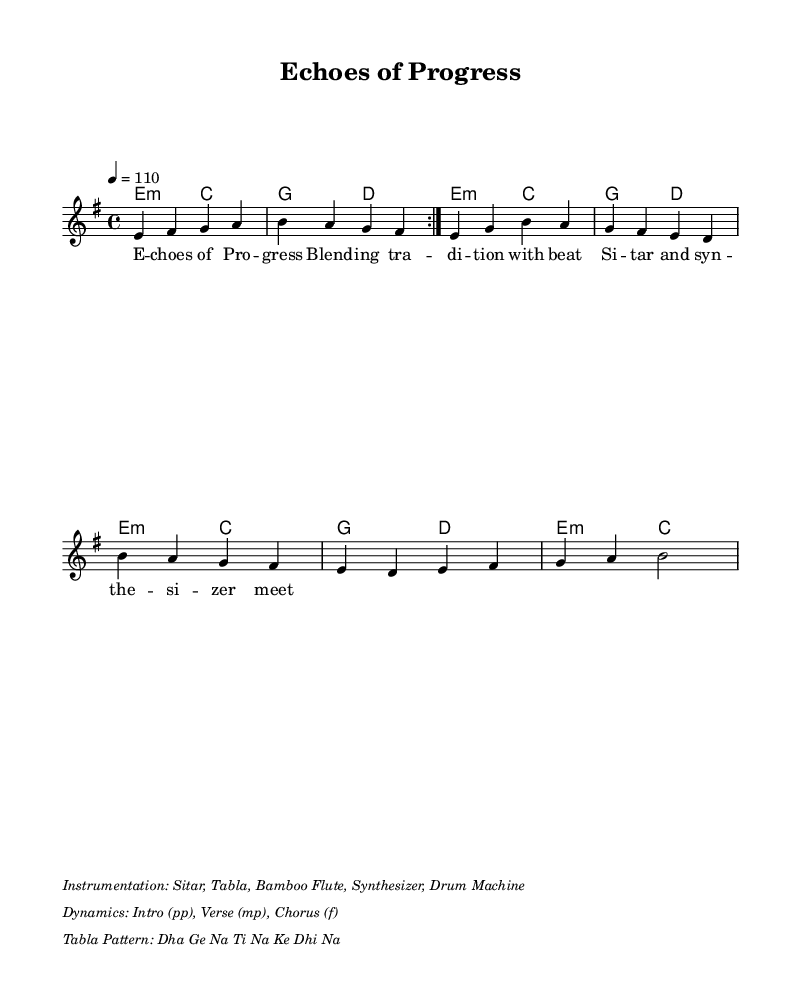What is the key signature of this music? The key signature is indicated by the sharp signs (the F#) in the sheet music, which reveals that it is in E minor.
Answer: E minor What is the time signature of the piece? The time signature is found at the beginning of the score; since it shows 4/4, this indicates that there are four beats in a measure and a quarter note gets one beat.
Answer: 4/4 What is the tempo marking of the music? The tempo is specified at the start with "4 = 110," which means there are 110 beats per minute, providing a fast pace to the music.
Answer: 110 How many times is the intro repeated? The score indicates "repeat volta 2" for the intro, meaning it should be played twice before moving to the next section.
Answer: 2 What instruments are included in the instrumentation? The instrumentation is listed in the markup section of the code, detailing all the instruments used in the piece, which includes the sitar, tabla, bamboo flute, synthesizer, and drum machine.
Answer: Sitar, Tabla, Bamboo Flute, Synthesizer, Drum Machine What dynamics are indicated for the chorus? The dynamics mark for the chorus specifies "f," which stands for forte, suggesting that this section should be played loudly compared to the other segments.
Answer: f What is the tabla pattern used in this music? The tabla pattern is explicitly noted in the markup section, listed as "Dha Ge Na Ti Na Ke Dhi Na," providing the rhythmic pattern for the percussion.
Answer: Dha Ge Na Ti Na Ke Dhi Na 